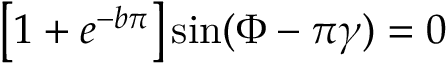Convert formula to latex. <formula><loc_0><loc_0><loc_500><loc_500>\left [ 1 + e ^ { - b \pi } \right ] \sin ( \Phi - \pi \gamma ) = 0</formula> 